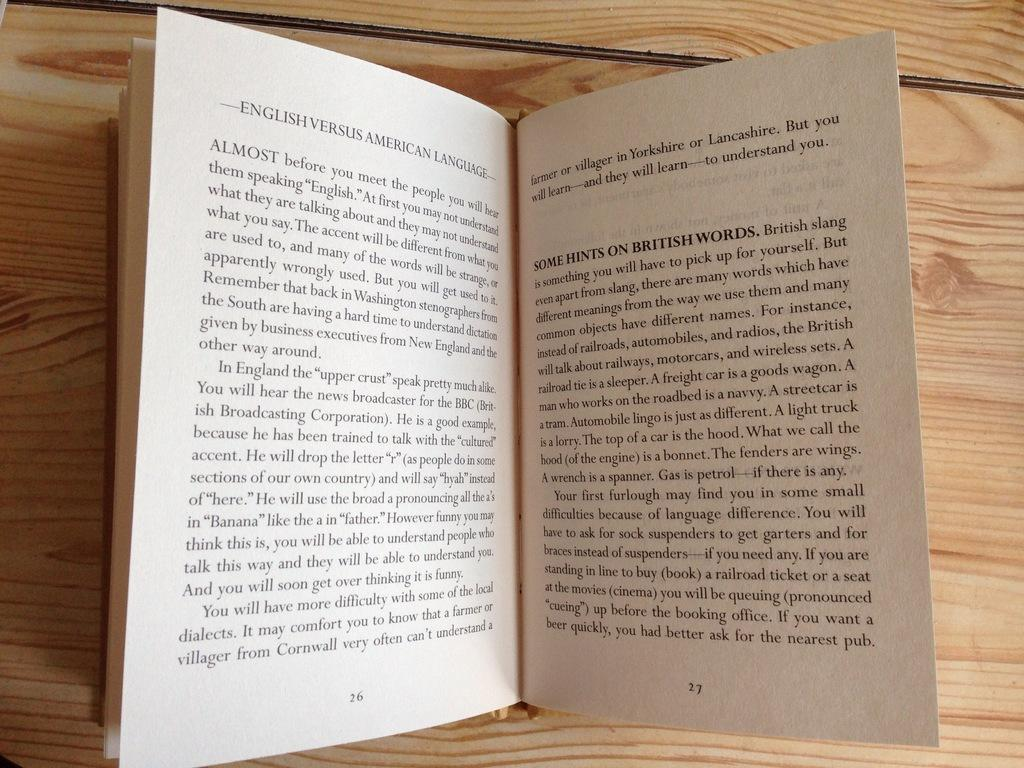<image>
Present a compact description of the photo's key features. A book has been written about the English vs American language 